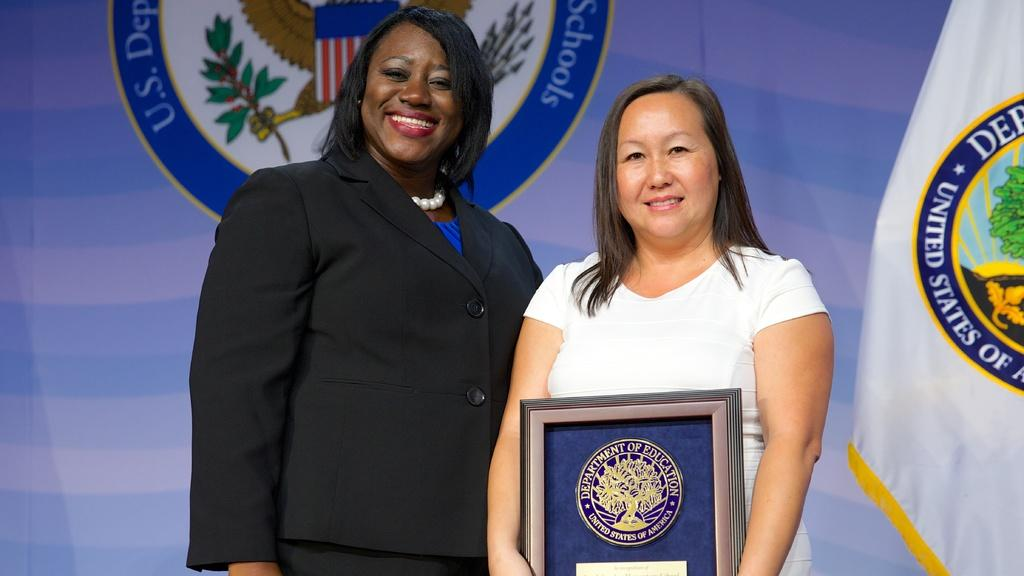<image>
Render a clear and concise summary of the photo. A woman is presenting an award to another woman with the United States Presidential Seal in the background. 